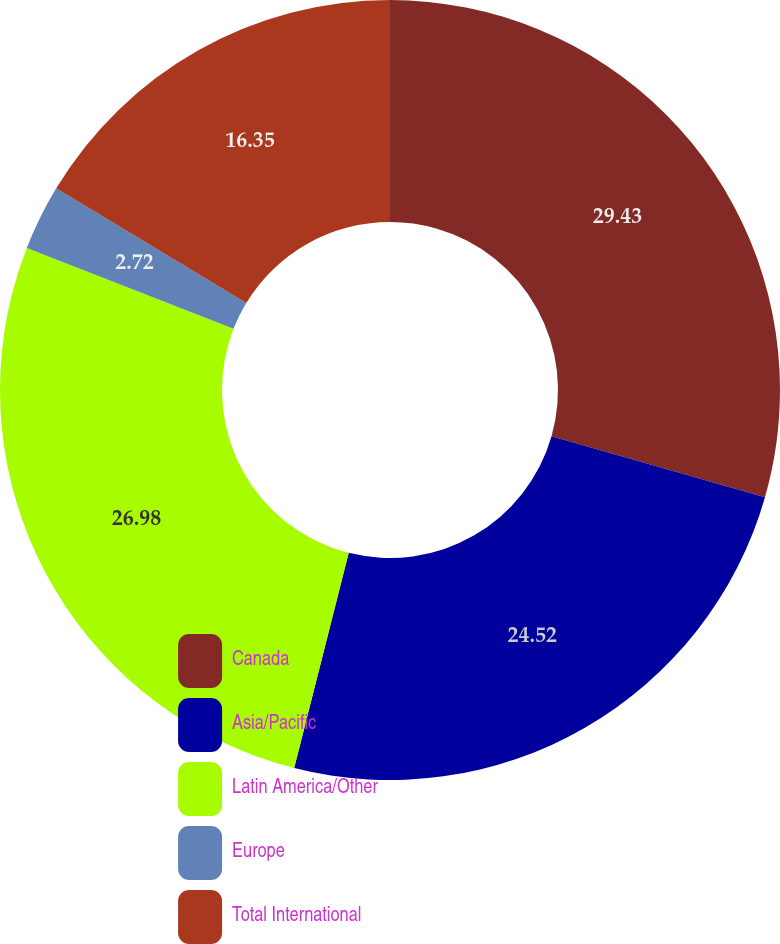<chart> <loc_0><loc_0><loc_500><loc_500><pie_chart><fcel>Canada<fcel>Asia/Pacific<fcel>Latin America/Other<fcel>Europe<fcel>Total International<nl><fcel>29.43%<fcel>24.52%<fcel>26.98%<fcel>2.72%<fcel>16.35%<nl></chart> 